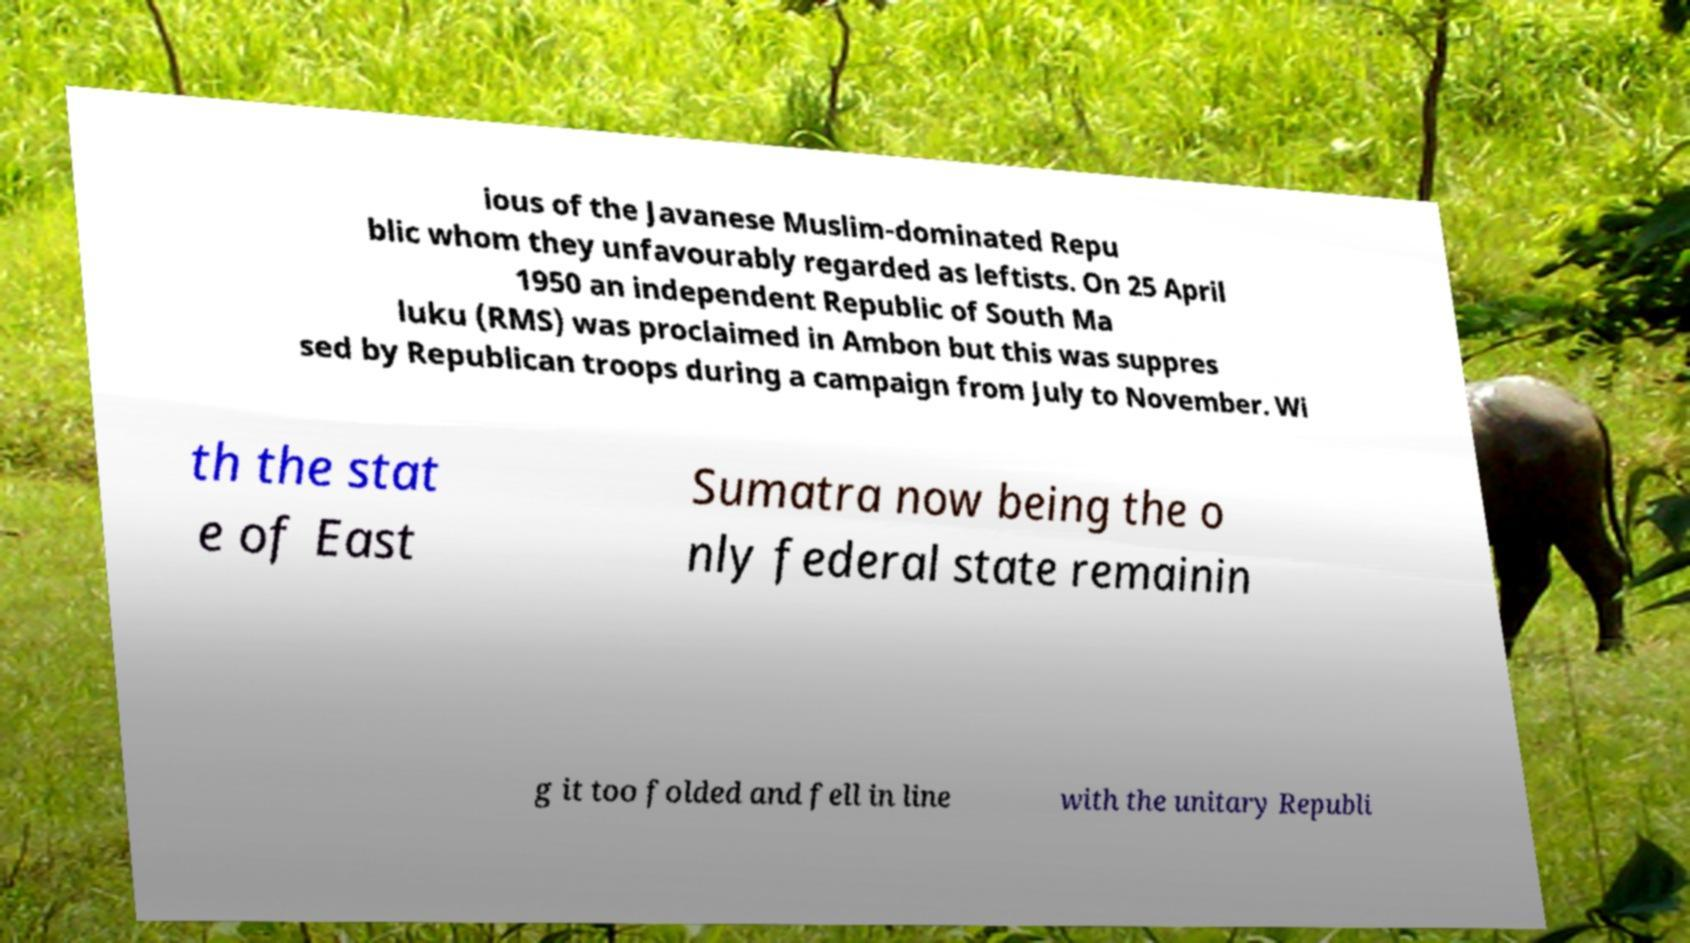For documentation purposes, I need the text within this image transcribed. Could you provide that? ious of the Javanese Muslim-dominated Repu blic whom they unfavourably regarded as leftists. On 25 April 1950 an independent Republic of South Ma luku (RMS) was proclaimed in Ambon but this was suppres sed by Republican troops during a campaign from July to November. Wi th the stat e of East Sumatra now being the o nly federal state remainin g it too folded and fell in line with the unitary Republi 